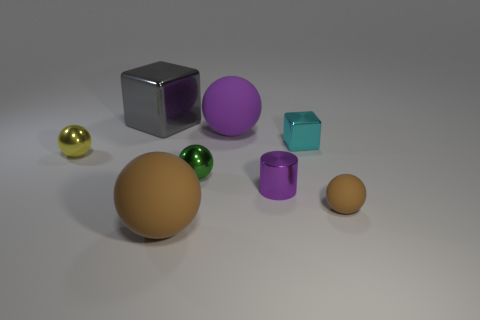Subtract all yellow balls. How many balls are left? 4 Subtract all yellow spheres. How many spheres are left? 4 Subtract all red balls. Subtract all purple cylinders. How many balls are left? 5 Add 2 brown spheres. How many objects exist? 10 Subtract all spheres. How many objects are left? 3 Subtract all big brown rubber things. Subtract all tiny spheres. How many objects are left? 4 Add 6 tiny yellow things. How many tiny yellow things are left? 7 Add 4 tiny cyan cylinders. How many tiny cyan cylinders exist? 4 Subtract 0 blue cylinders. How many objects are left? 8 